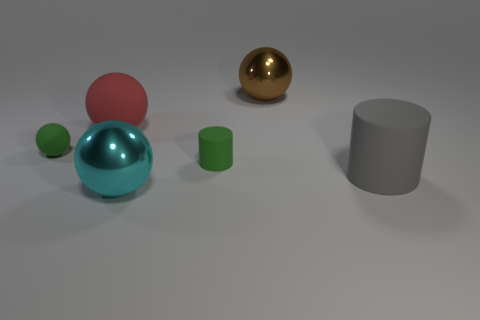Are there any other things that have the same color as the big rubber sphere?
Your answer should be very brief. No. Is the material of the red ball the same as the small green object that is left of the large matte sphere?
Your answer should be compact. Yes. What is the material of the small thing that is the same shape as the big red thing?
Keep it short and to the point. Rubber. Are the ball in front of the large gray thing and the brown ball behind the red rubber sphere made of the same material?
Your answer should be compact. Yes. What color is the big ball in front of the large matte thing to the right of the shiny thing on the left side of the brown metallic object?
Your answer should be very brief. Cyan. How many other things are the same shape as the red matte object?
Keep it short and to the point. 3. Is the tiny cylinder the same color as the tiny matte ball?
Make the answer very short. Yes. What number of things are either small green objects or brown shiny balls right of the small matte cylinder?
Give a very brief answer. 3. Are there any brown shiny objects that have the same size as the red sphere?
Provide a succinct answer. Yes. Does the green ball have the same material as the large gray object?
Provide a short and direct response. Yes. 